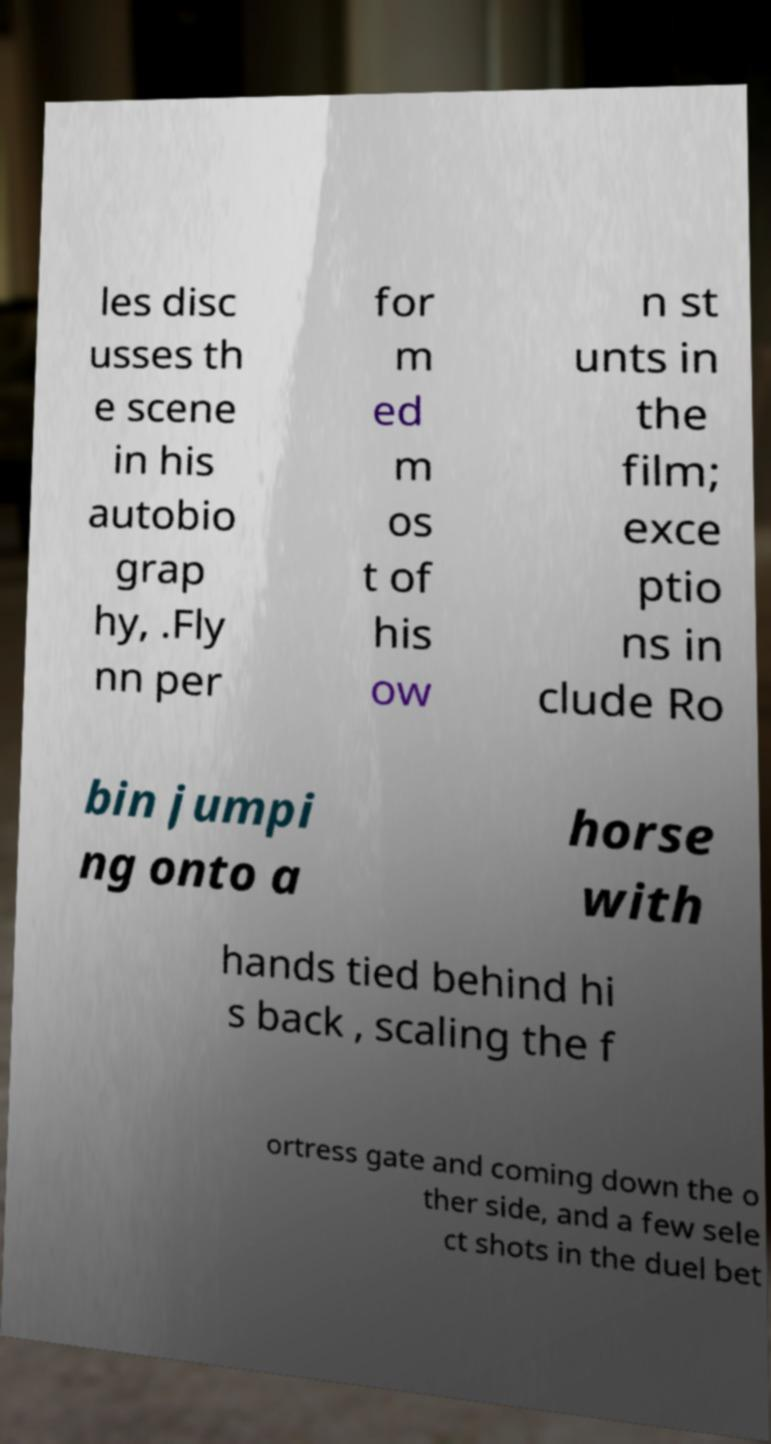Can you read and provide the text displayed in the image?This photo seems to have some interesting text. Can you extract and type it out for me? les disc usses th e scene in his autobio grap hy, .Fly nn per for m ed m os t of his ow n st unts in the film; exce ptio ns in clude Ro bin jumpi ng onto a horse with hands tied behind hi s back , scaling the f ortress gate and coming down the o ther side, and a few sele ct shots in the duel bet 